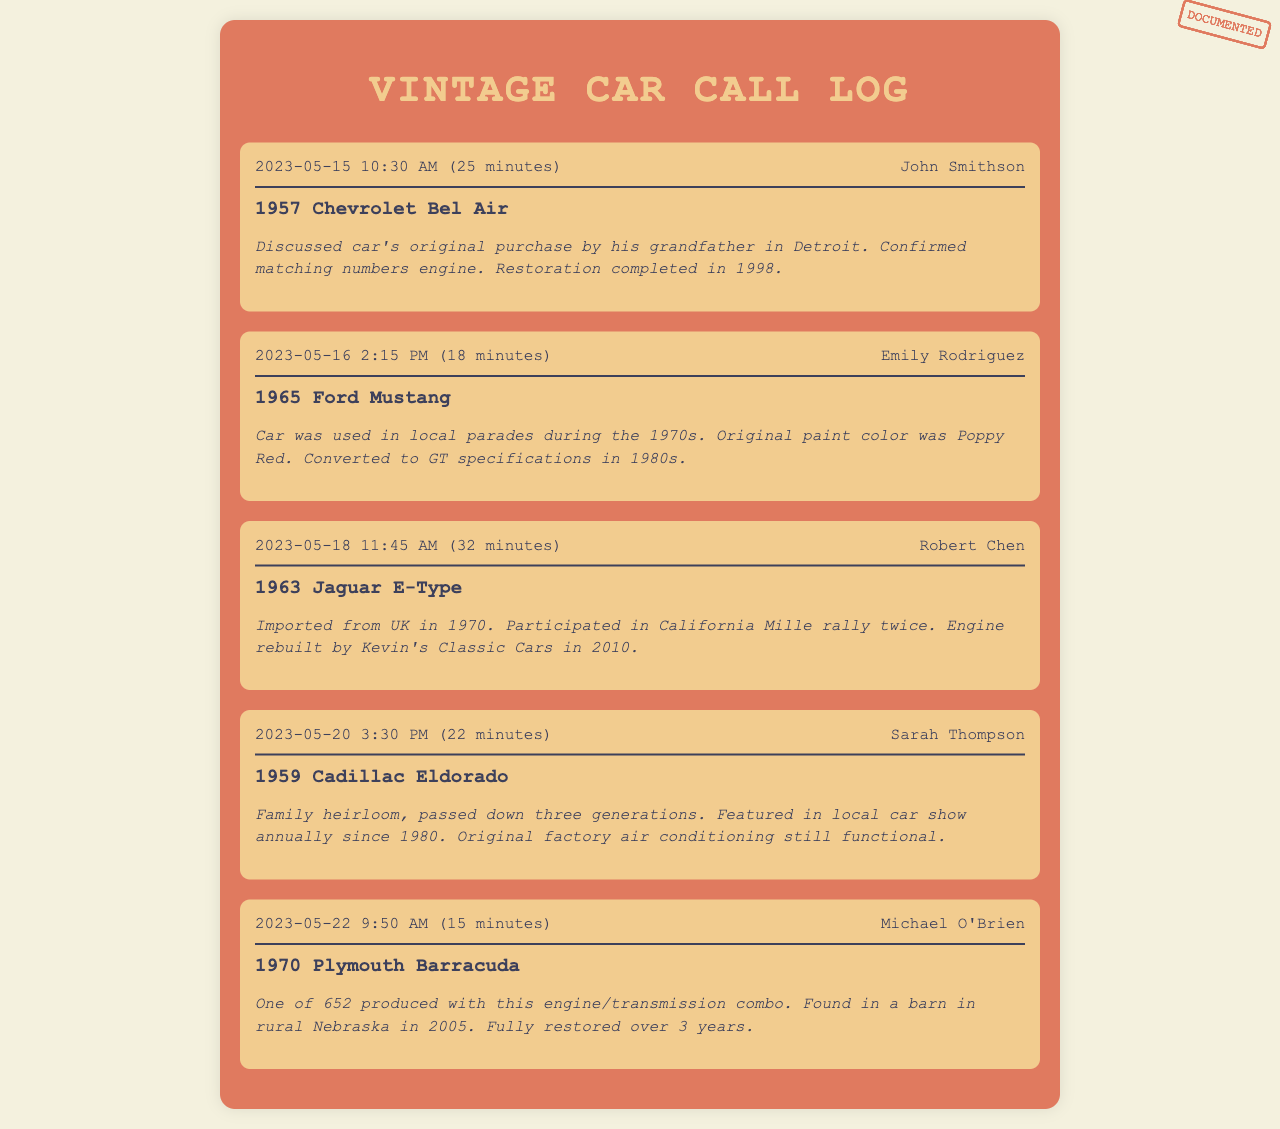What is the name of the first caller? The name of the first caller is listed at the top of the first call log entry.
Answer: John Smithson What car model does Emily Rodriguez own? The car model is mentioned directly under her name in the call log entry.
Answer: 1965 Ford Mustang When was the 1963 Jaguar E-Type imported from the UK? The date can be found within the notes of Robert Chen's call log.
Answer: 1970 How long did the call with Michael O'Brien last? The duration of the call is indicated at the beginning of the call log entry.
Answer: 15 minutes Which car was mentioned as a family heirloom? This information is found in the notes of Sarah Thompson's call log.
Answer: 1959 Cadillac Eldorado How many generations has the Cadillac Eldorado been passed down? The number of generations is specified in the notes of Sarah Thompson's call log.
Answer: Three generations Which car model was restored over three years? This detail is included in the notes for Michael O'Brien's call log.
Answer: 1970 Plymouth Barracuda What significant event did the 1965 Ford Mustang participate in during the 1970s? This information is stated in the notes section of Emily Rodriguez's call log.
Answer: Local parades 